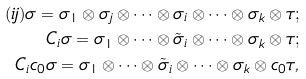Convert formula to latex. <formula><loc_0><loc_0><loc_500><loc_500>( i j ) \sigma = \sigma _ { 1 } \otimes \sigma _ { j } \otimes \cdots \otimes \sigma _ { i } \otimes \cdots \otimes \sigma _ { k } \otimes \tau ; \\ C _ { i } \sigma = \sigma _ { 1 } \otimes \cdots \otimes \tilde { \sigma } _ { i } \otimes \cdots \otimes \sigma _ { k } \otimes \tau ; \\ C _ { i } c _ { 0 } \sigma = \sigma _ { 1 } \otimes \cdots \otimes \tilde { \sigma } _ { i } \otimes \cdots \otimes \sigma _ { k } \otimes c _ { 0 } \tau ,</formula> 